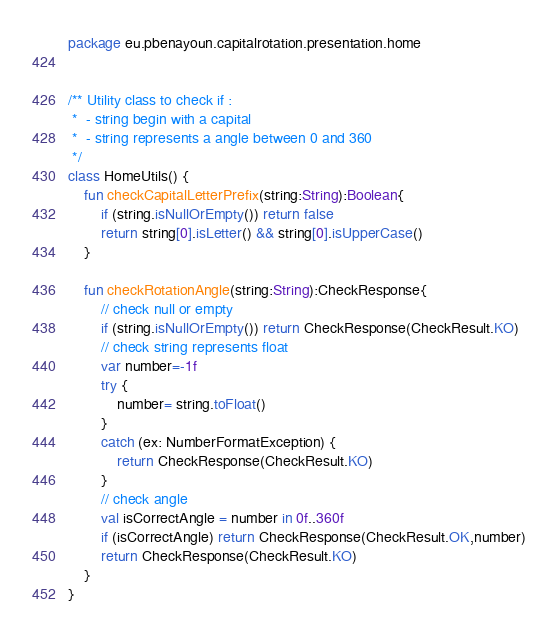Convert code to text. <code><loc_0><loc_0><loc_500><loc_500><_Kotlin_>package eu.pbenayoun.capitalrotation.presentation.home


/** Utility class to check if :
 *  - string begin with a capital
 *  - string represents a angle between 0 and 360
 */
class HomeUtils() {
    fun checkCapitalLetterPrefix(string:String):Boolean{
        if (string.isNullOrEmpty()) return false
        return string[0].isLetter() && string[0].isUpperCase()
    }

    fun checkRotationAngle(string:String):CheckResponse{
        // check null or empty
        if (string.isNullOrEmpty()) return CheckResponse(CheckResult.KO)
        // check string represents float
        var number=-1f
        try {
            number= string.toFloat()
        }
        catch (ex: NumberFormatException) {
            return CheckResponse(CheckResult.KO)
        }
        // check angle
        val isCorrectAngle = number in 0f..360f
        if (isCorrectAngle) return CheckResponse(CheckResult.OK,number)
        return CheckResponse(CheckResult.KO)
    }
}</code> 